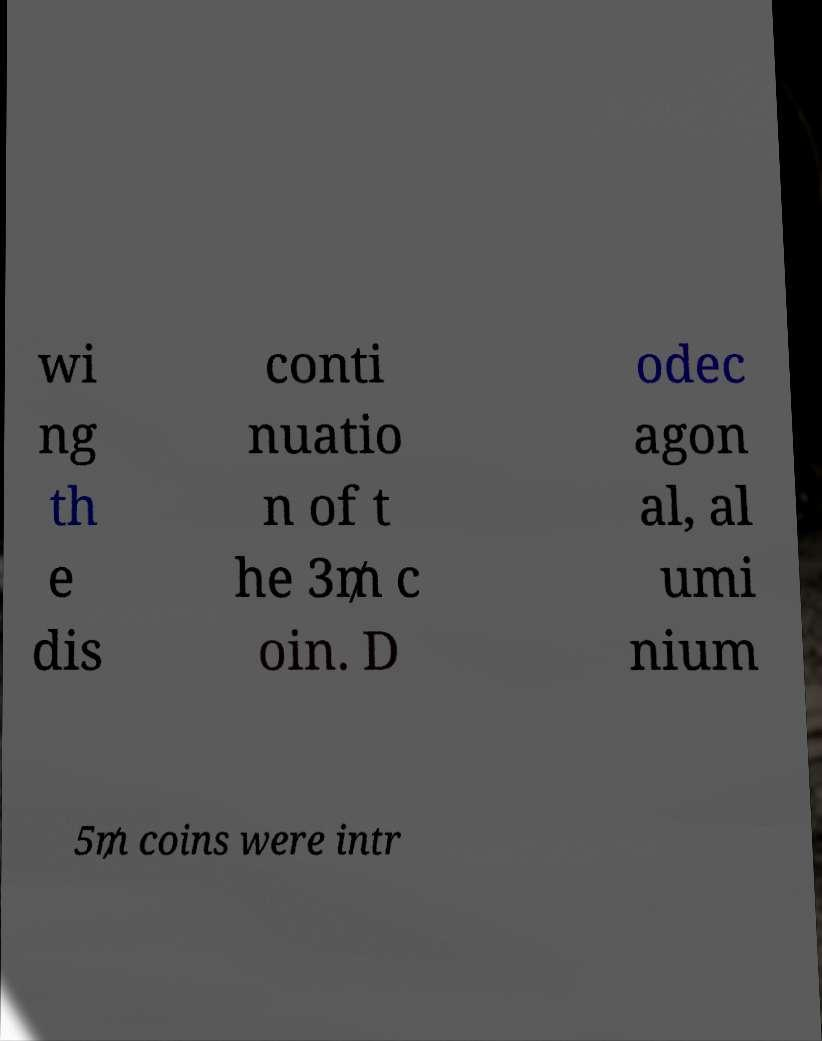Can you accurately transcribe the text from the provided image for me? wi ng th e dis conti nuatio n of t he 3₥ c oin. D odec agon al, al umi nium 5₥ coins were intr 